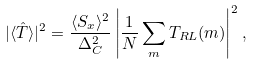Convert formula to latex. <formula><loc_0><loc_0><loc_500><loc_500>| \langle \hat { T } \rangle | ^ { 2 } = \frac { \langle S _ { x } \rangle ^ { 2 } } { \Delta ^ { 2 } _ { C } } \left | \frac { 1 } { N } \sum _ { m } T _ { R L } ( m ) \right | ^ { 2 } ,</formula> 